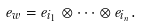<formula> <loc_0><loc_0><loc_500><loc_500>e _ { w } = e _ { i _ { 1 } } \otimes \cdots \otimes e _ { i _ { n } } .</formula> 